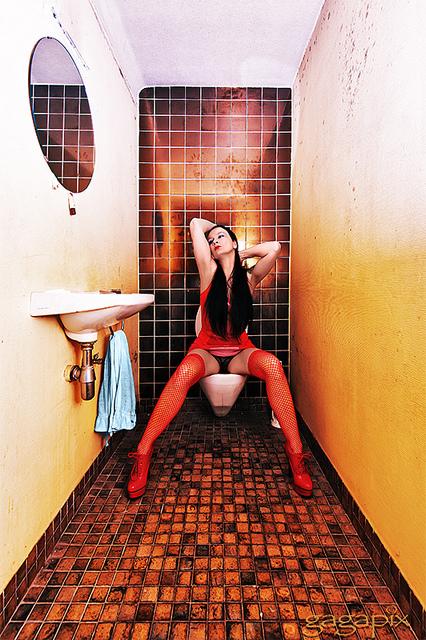What material are the floor tiles made of?
Be succinct. Wood. Where are the red net stockings?
Quick response, please. On woman's legs. Is the woman on a chair?
Give a very brief answer. No. 